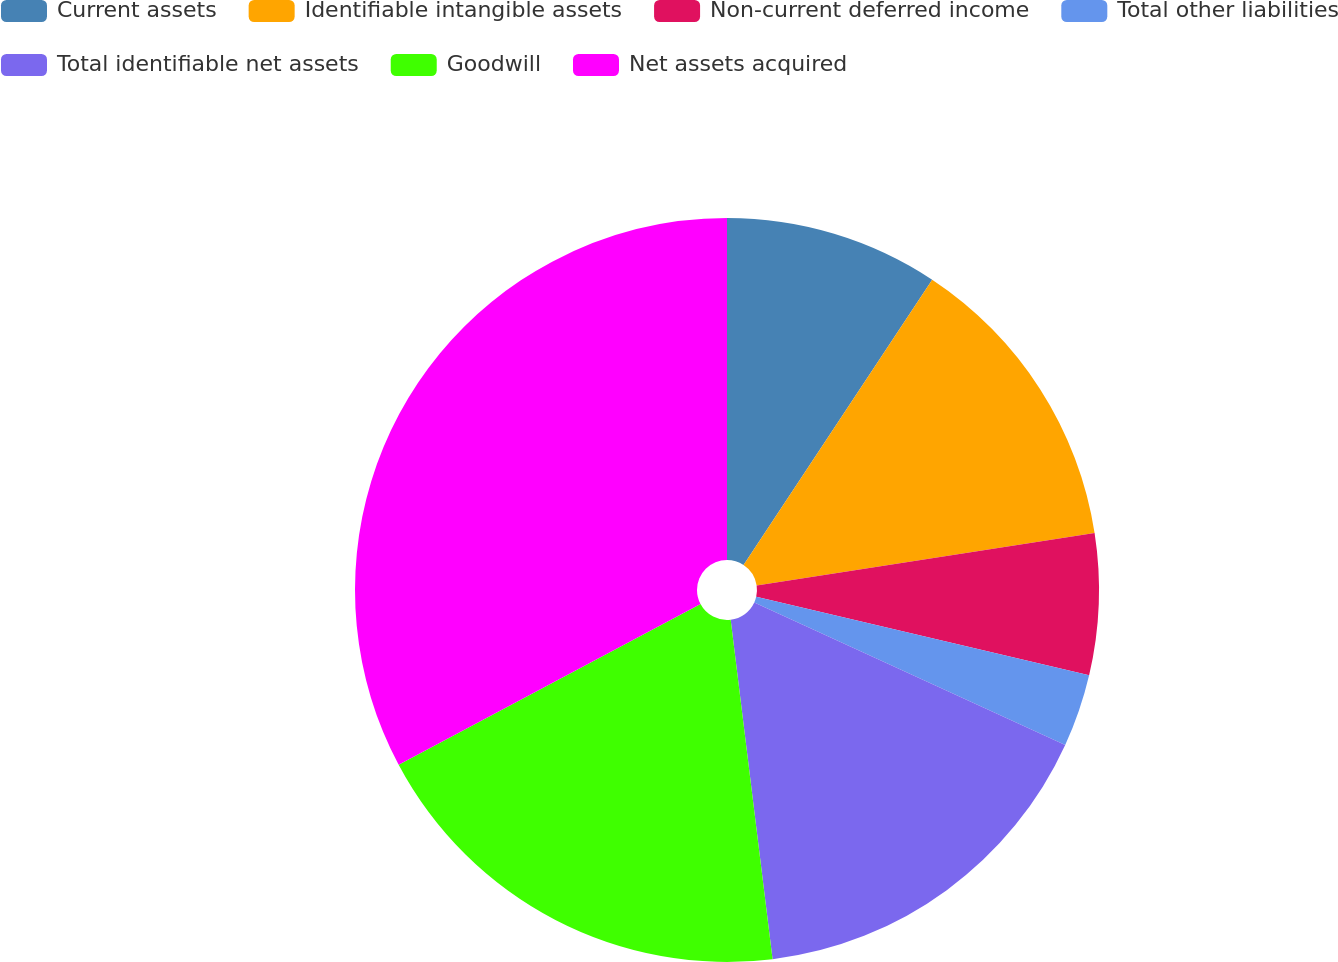Convert chart to OTSL. <chart><loc_0><loc_0><loc_500><loc_500><pie_chart><fcel>Current assets<fcel>Identifiable intangible assets<fcel>Non-current deferred income<fcel>Total other liabilities<fcel>Total identifiable net assets<fcel>Goodwill<fcel>Net assets acquired<nl><fcel>9.3%<fcel>13.25%<fcel>6.13%<fcel>3.16%<fcel>16.21%<fcel>19.17%<fcel>32.79%<nl></chart> 